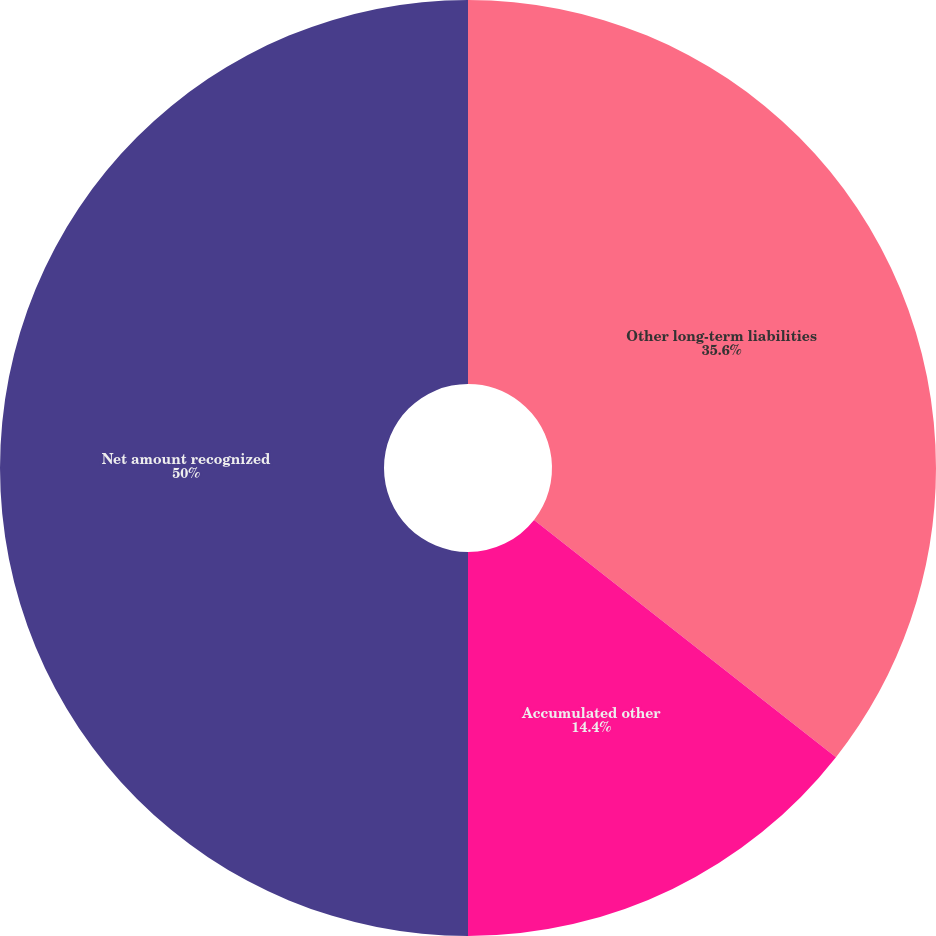Convert chart to OTSL. <chart><loc_0><loc_0><loc_500><loc_500><pie_chart><fcel>Other long-term liabilities<fcel>Accumulated other<fcel>Net amount recognized<nl><fcel>35.6%<fcel>14.4%<fcel>50.0%<nl></chart> 